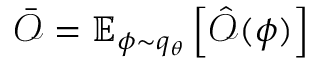Convert formula to latex. <formula><loc_0><loc_0><loc_500><loc_500>\bar { \mathcal { O } } = \mathbb { E } _ { \phi \sim q _ { \theta } } \left [ \hat { \mathcal { O } } ( \phi ) \right ]</formula> 